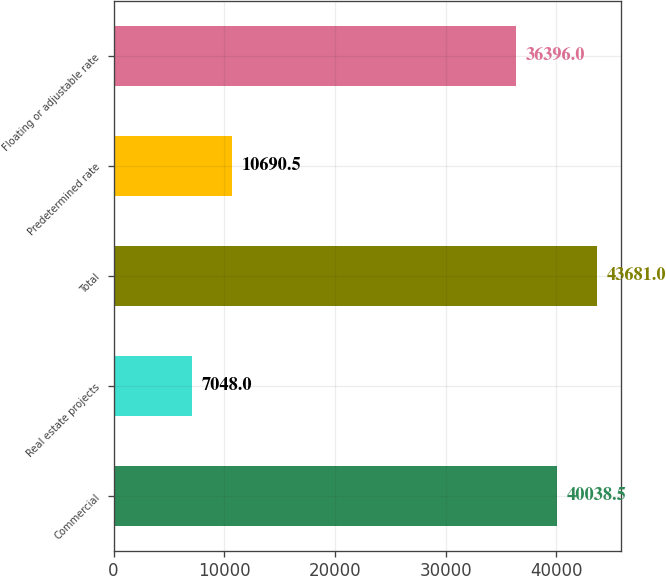Convert chart. <chart><loc_0><loc_0><loc_500><loc_500><bar_chart><fcel>Commercial<fcel>Real estate projects<fcel>Total<fcel>Predetermined rate<fcel>Floating or adjustable rate<nl><fcel>40038.5<fcel>7048<fcel>43681<fcel>10690.5<fcel>36396<nl></chart> 